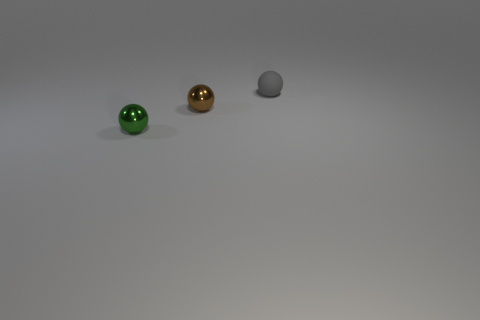What material is the sphere that is both behind the small green sphere and in front of the small gray rubber ball?
Your response must be concise. Metal. Are there any other things that have the same shape as the gray rubber thing?
Give a very brief answer. Yes. The other small sphere that is the same material as the small brown sphere is what color?
Your answer should be very brief. Green. What number of things are either small blue metallic cylinders or brown shiny things?
Your answer should be compact. 1. There is a green ball; is it the same size as the shiny object behind the green object?
Your answer should be very brief. Yes. There is a thing to the left of the shiny sphere behind the tiny shiny thing that is on the left side of the brown ball; what color is it?
Provide a short and direct response. Green. What color is the matte ball?
Your answer should be very brief. Gray. Is the number of objects to the right of the tiny brown metallic object greater than the number of small green metal things that are behind the small green object?
Give a very brief answer. Yes. There is a green metallic thing; is its shape the same as the small shiny object behind the green metal ball?
Give a very brief answer. Yes. Does the shiny ball that is behind the green object have the same size as the metal ball left of the tiny brown metal thing?
Provide a succinct answer. Yes. 